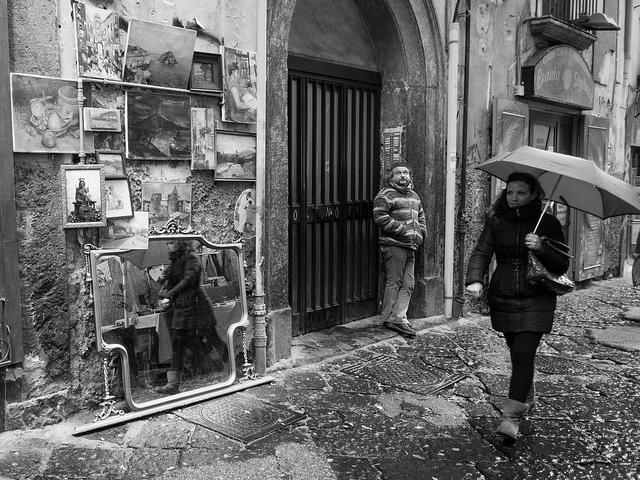Is the man on the left bald?
Concise answer only. No. What is the woman holding?
Answer briefly. Umbrella. How many paintings are on the wall?
Give a very brief answer. 14. Is the road made of stones?
Be succinct. Yes. 